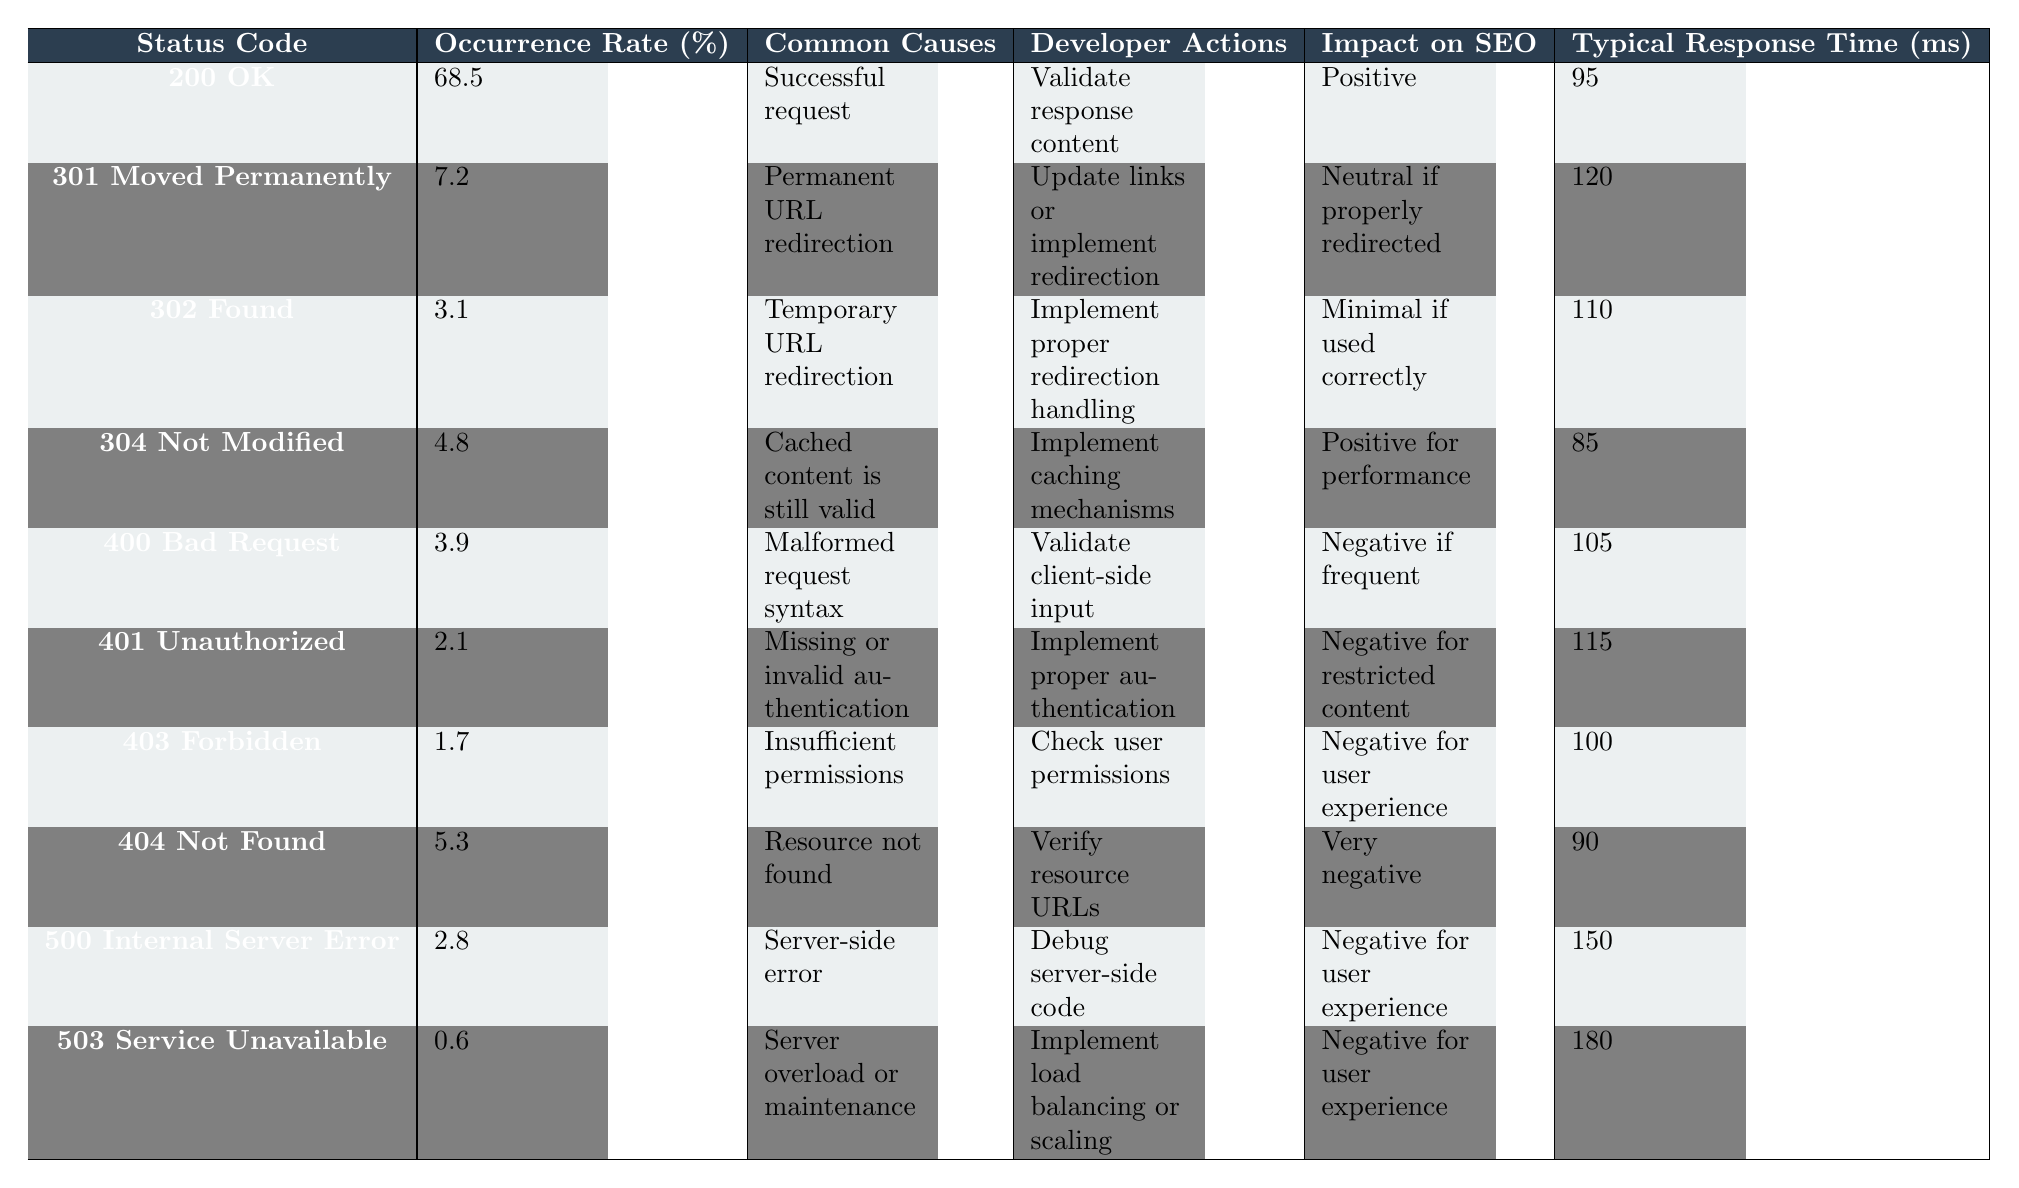What is the occurrence rate of the "404 Not Found" status code? The table shows that the occurrence rate for "404 Not Found" is listed under the "Occurrence Rate (%)" column. Looking at that row, the corresponding value is 5.3.
Answer: 5.3 Which status code has the highest occurrence rate? By examining the "Occurrence Rate (%)" column, it's clear that "200 OK" has the highest value of 68.5 compared to the other status codes.
Answer: 200 OK What are the common causes for the "500 Internal Server Error"? The "Common Causes" column for the "500 Internal Server Error" status code lists "Server-side error." This is the explicit cause mentioned in the table.
Answer: Server-side error What is the impact on SEO for the "301 Moved Permanently" status code? The "Impact on SEO" column for the "301 Moved Permanently" status code states "Neutral if properly redirected." This indicates the SEO implication when the redirect is handled correctly.
Answer: Neutral if properly redirected What is the average occurrence rate of all status codes listed? To find the average, I need to sum up all the occurrence rates: (68.5 + 7.2 + 3.1 + 4.8 + 3.9 + 2.1 + 1.7 + 5.3 + 2.8 + 0.6) = 94.0. Then divide by the number of status codes (10): 94.0 / 10 = 9.4.
Answer: 9.4 Is the response time for "503 Service Unavailable" higher than "500 Internal Server Error"? Looking at the "Typical Response Time (ms)" column, "503 Service Unavailable" has a value of 180 ms, while "500 Internal Server Error" has a value of 150 ms. Since 180 is greater than 150, the answer is yes.
Answer: Yes What is the total occurrence rate of the "400 Bad Request" and "401 Unauthorized"? The occurrence rate for "400 Bad Request" is 3.9, and for "401 Unauthorized," it’s 2.1. I sum these two values: 3.9 + 2.1 = 6.0.
Answer: 6.0 How many status codes have a negative impact on SEO? Analyzing the "Impact on SEO" column, the status codes "400 Bad Request," "401 Unauthorized," "403 Forbidden," "404 Not Found," "500 Internal Server Error," and "503 Service Unavailable" each have negative impacts, totaling 6 codes.
Answer: 6 What developer action is suggested for the "404 Not Found" status code? According to the "Developer Actions" listed for the "404 Not Found" status code, the suggestion given is to "Verify resource URLs." This is what developers should do in this case.
Answer: Verify resource URLs Which status code has the least occurrence rate and what is its impact on SEO? The status code with the least occurrence rate is "503 Service Unavailable" at 0.6%. Its impact on SEO is labeled as "Negative for user experience."
Answer: 503 Service Unavailable, Negative for user experience What is the typical response time for the status code with the highest occurrence rate? The status code with the highest occurrence rate is "200 OK," and its corresponding typical response time is 95 ms as shown in the "Typical Response Time (ms)" column.
Answer: 95 ms 